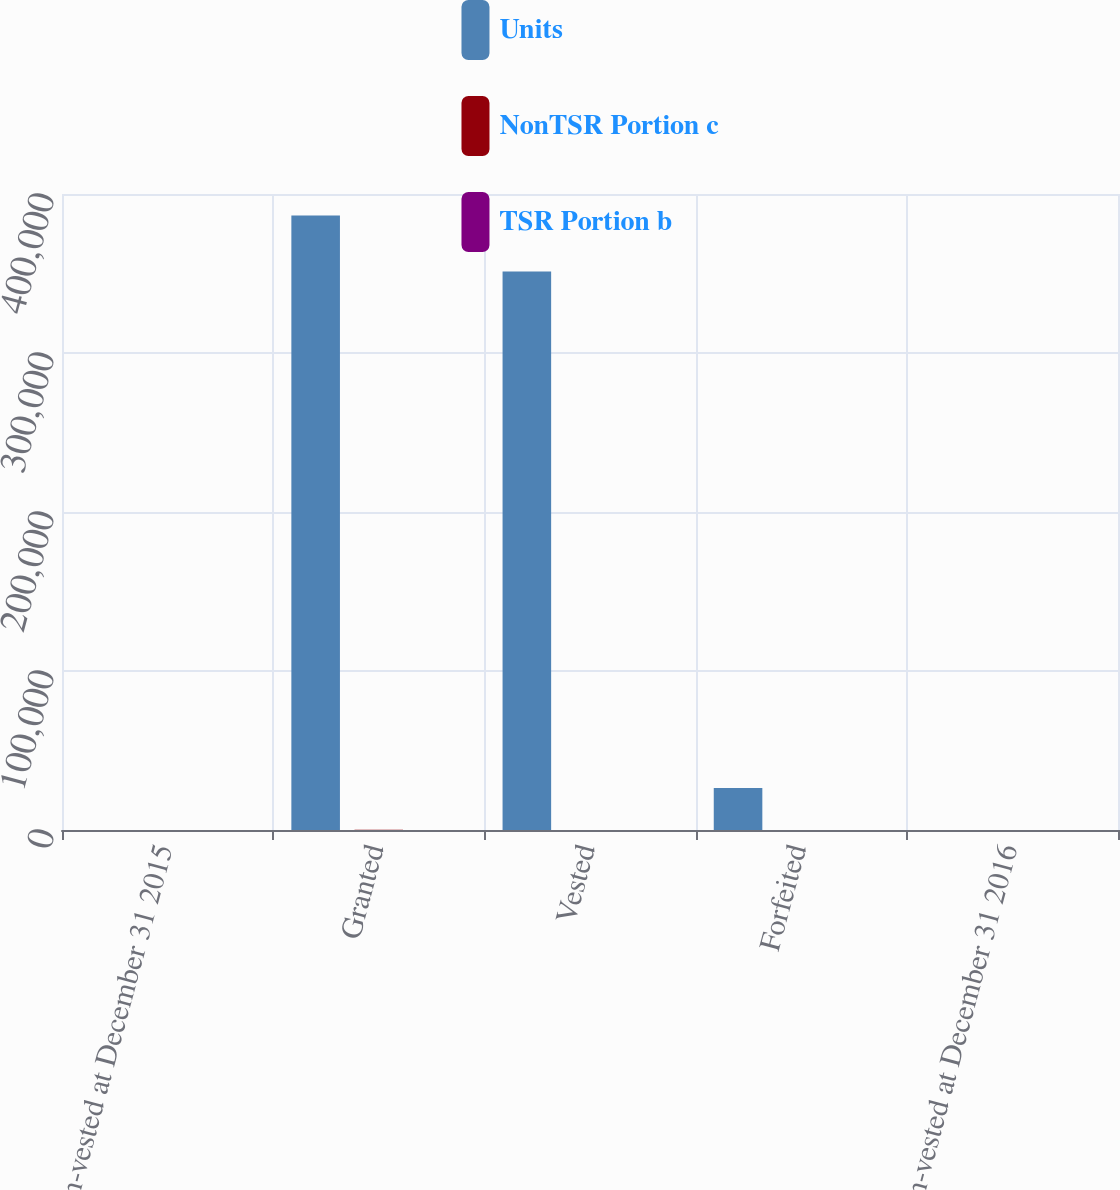<chart> <loc_0><loc_0><loc_500><loc_500><stacked_bar_chart><ecel><fcel>Non-vested at December 31 2015<fcel>Granted<fcel>Vested<fcel>Forfeited<fcel>Non-vested at December 31 2016<nl><fcel>Units<fcel>61.03<fcel>386400<fcel>351230<fcel>26372<fcel>61.03<nl><fcel>NonTSR Portion c<fcel>45.26<fcel>83.16<fcel>55.16<fcel>48.48<fcel>55.45<nl><fcel>TSR Portion b<fcel>58.08<fcel>72.1<fcel>57.96<fcel>61.03<fcel>63.03<nl></chart> 